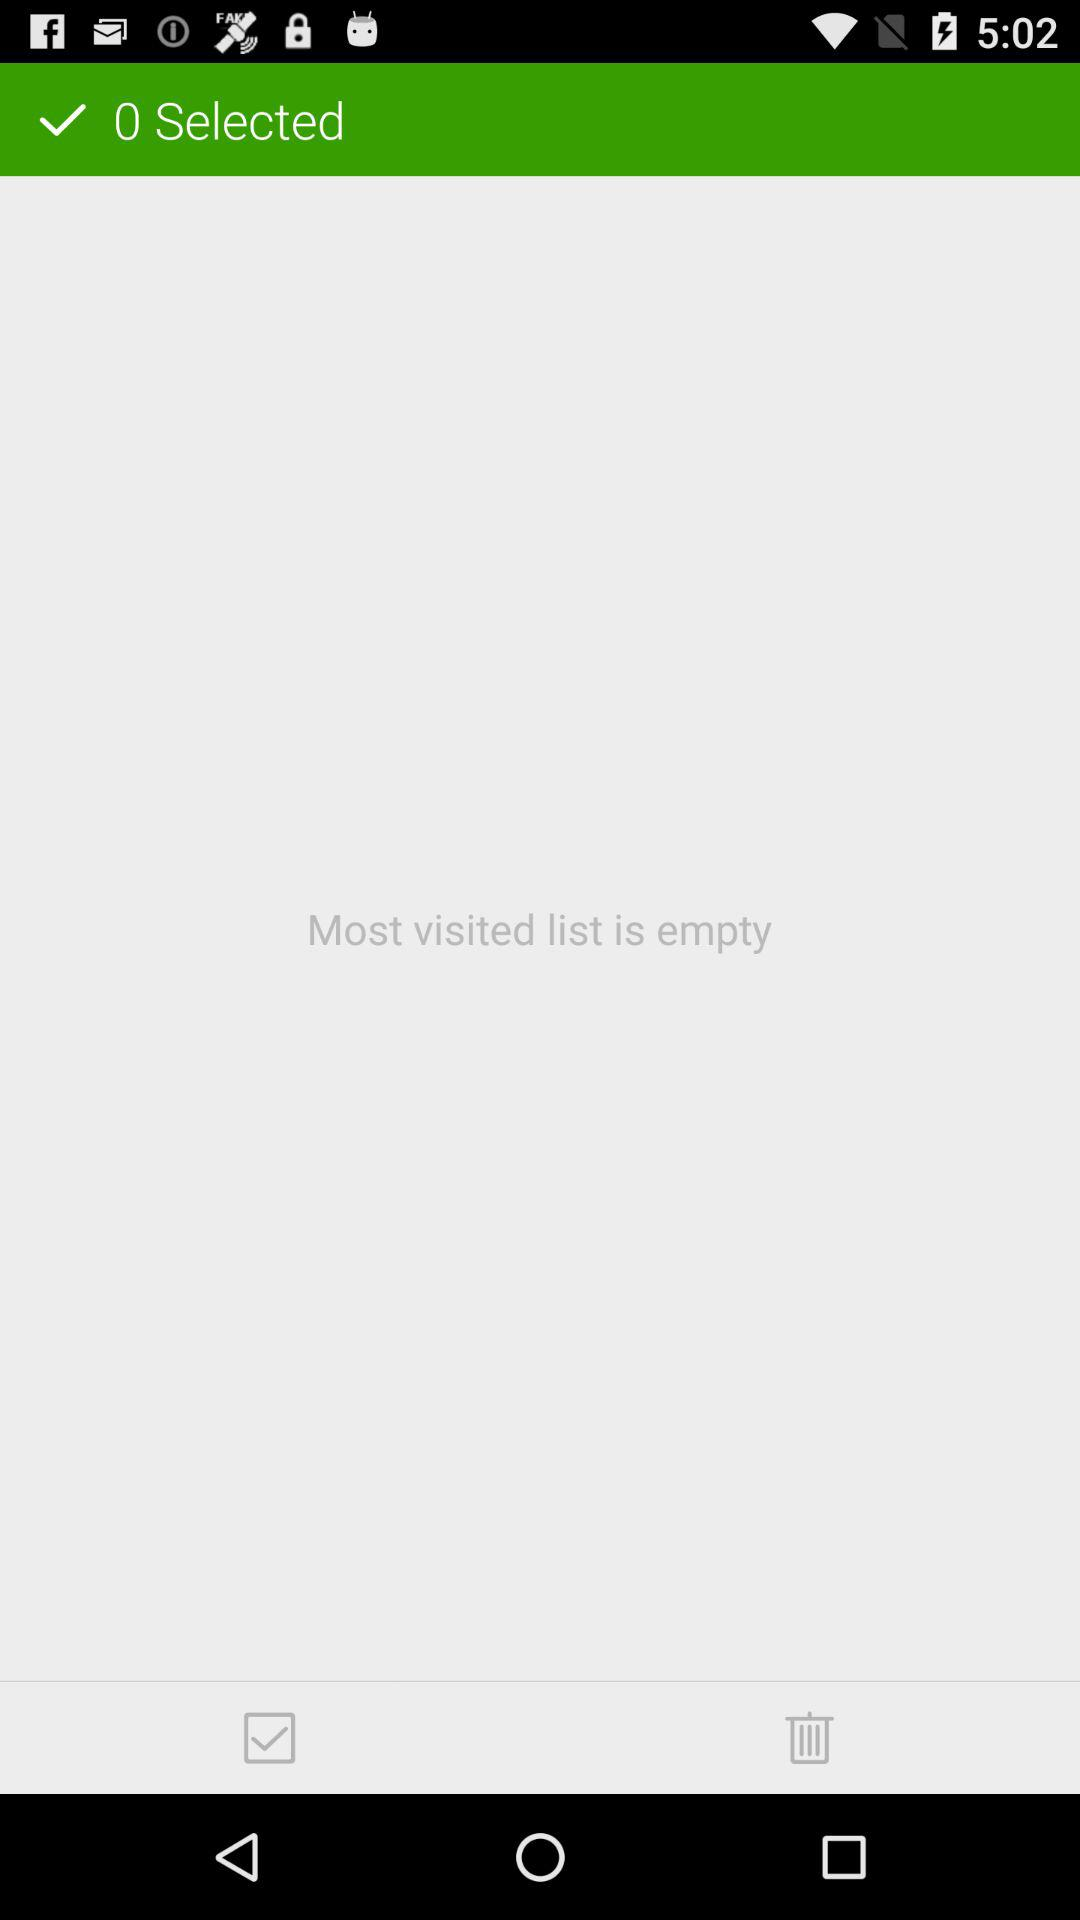What is the count of "Selected"? The count is 0. 